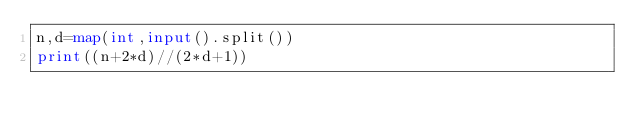Convert code to text. <code><loc_0><loc_0><loc_500><loc_500><_Python_>n,d=map(int,input().split())
print((n+2*d)//(2*d+1))</code> 